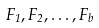<formula> <loc_0><loc_0><loc_500><loc_500>F _ { 1 } , F _ { 2 } , \dots , F _ { b }</formula> 